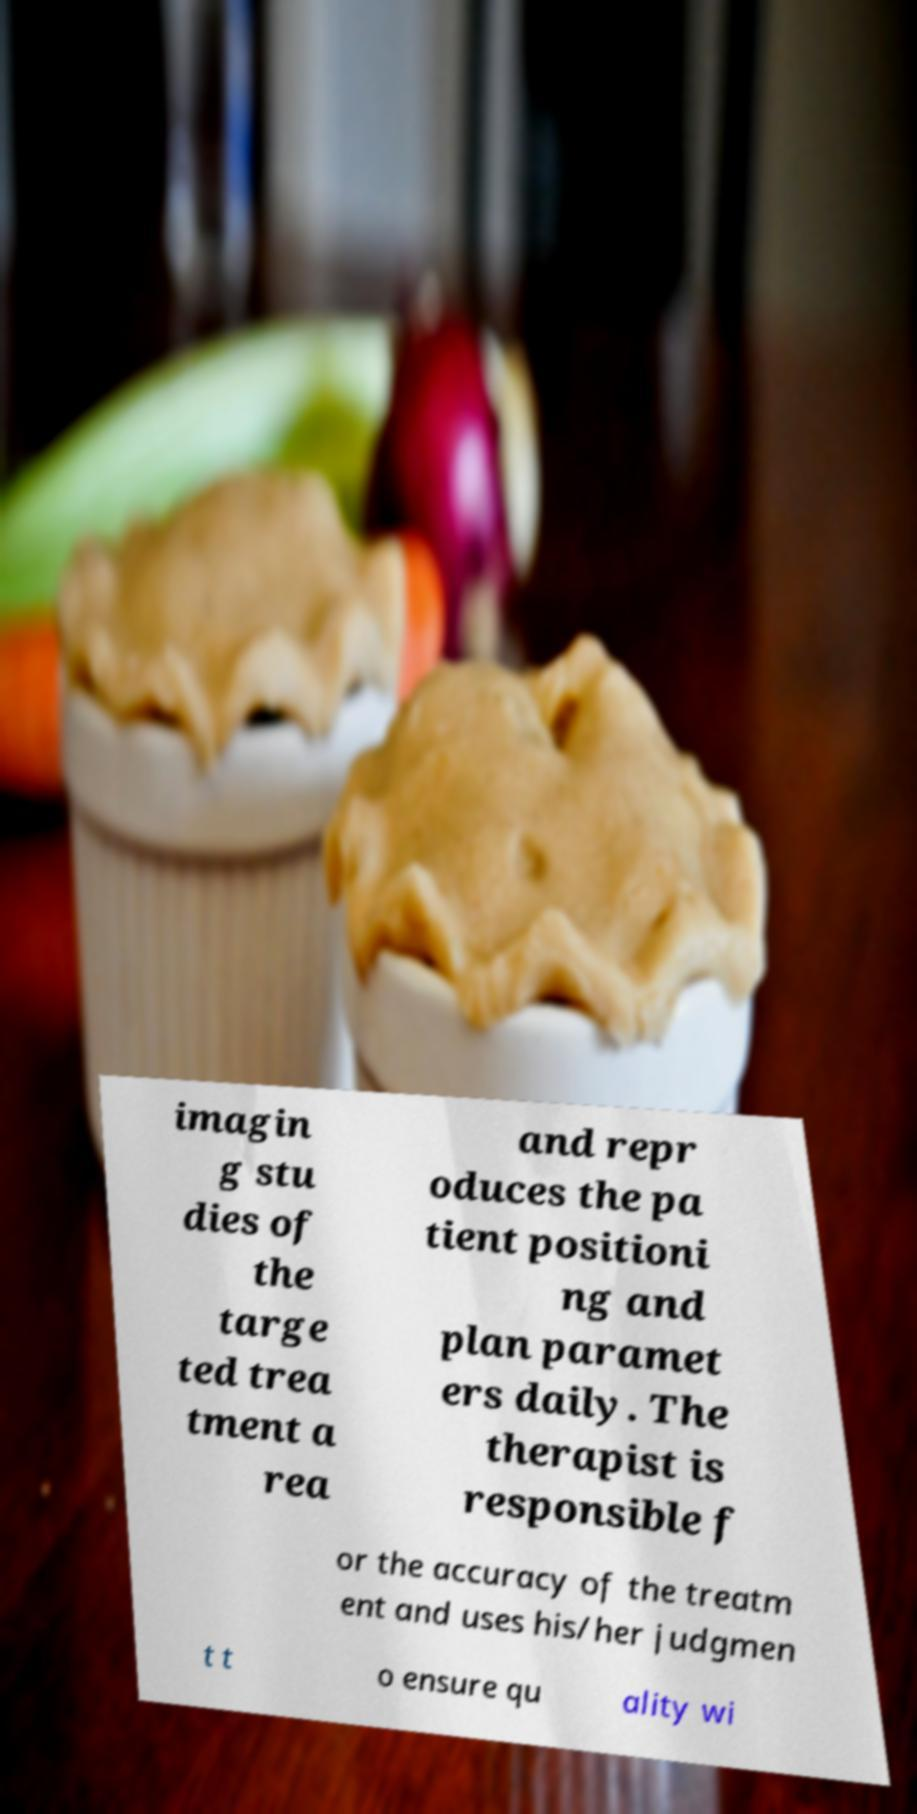Please identify and transcribe the text found in this image. imagin g stu dies of the targe ted trea tment a rea and repr oduces the pa tient positioni ng and plan paramet ers daily. The therapist is responsible f or the accuracy of the treatm ent and uses his/her judgmen t t o ensure qu ality wi 